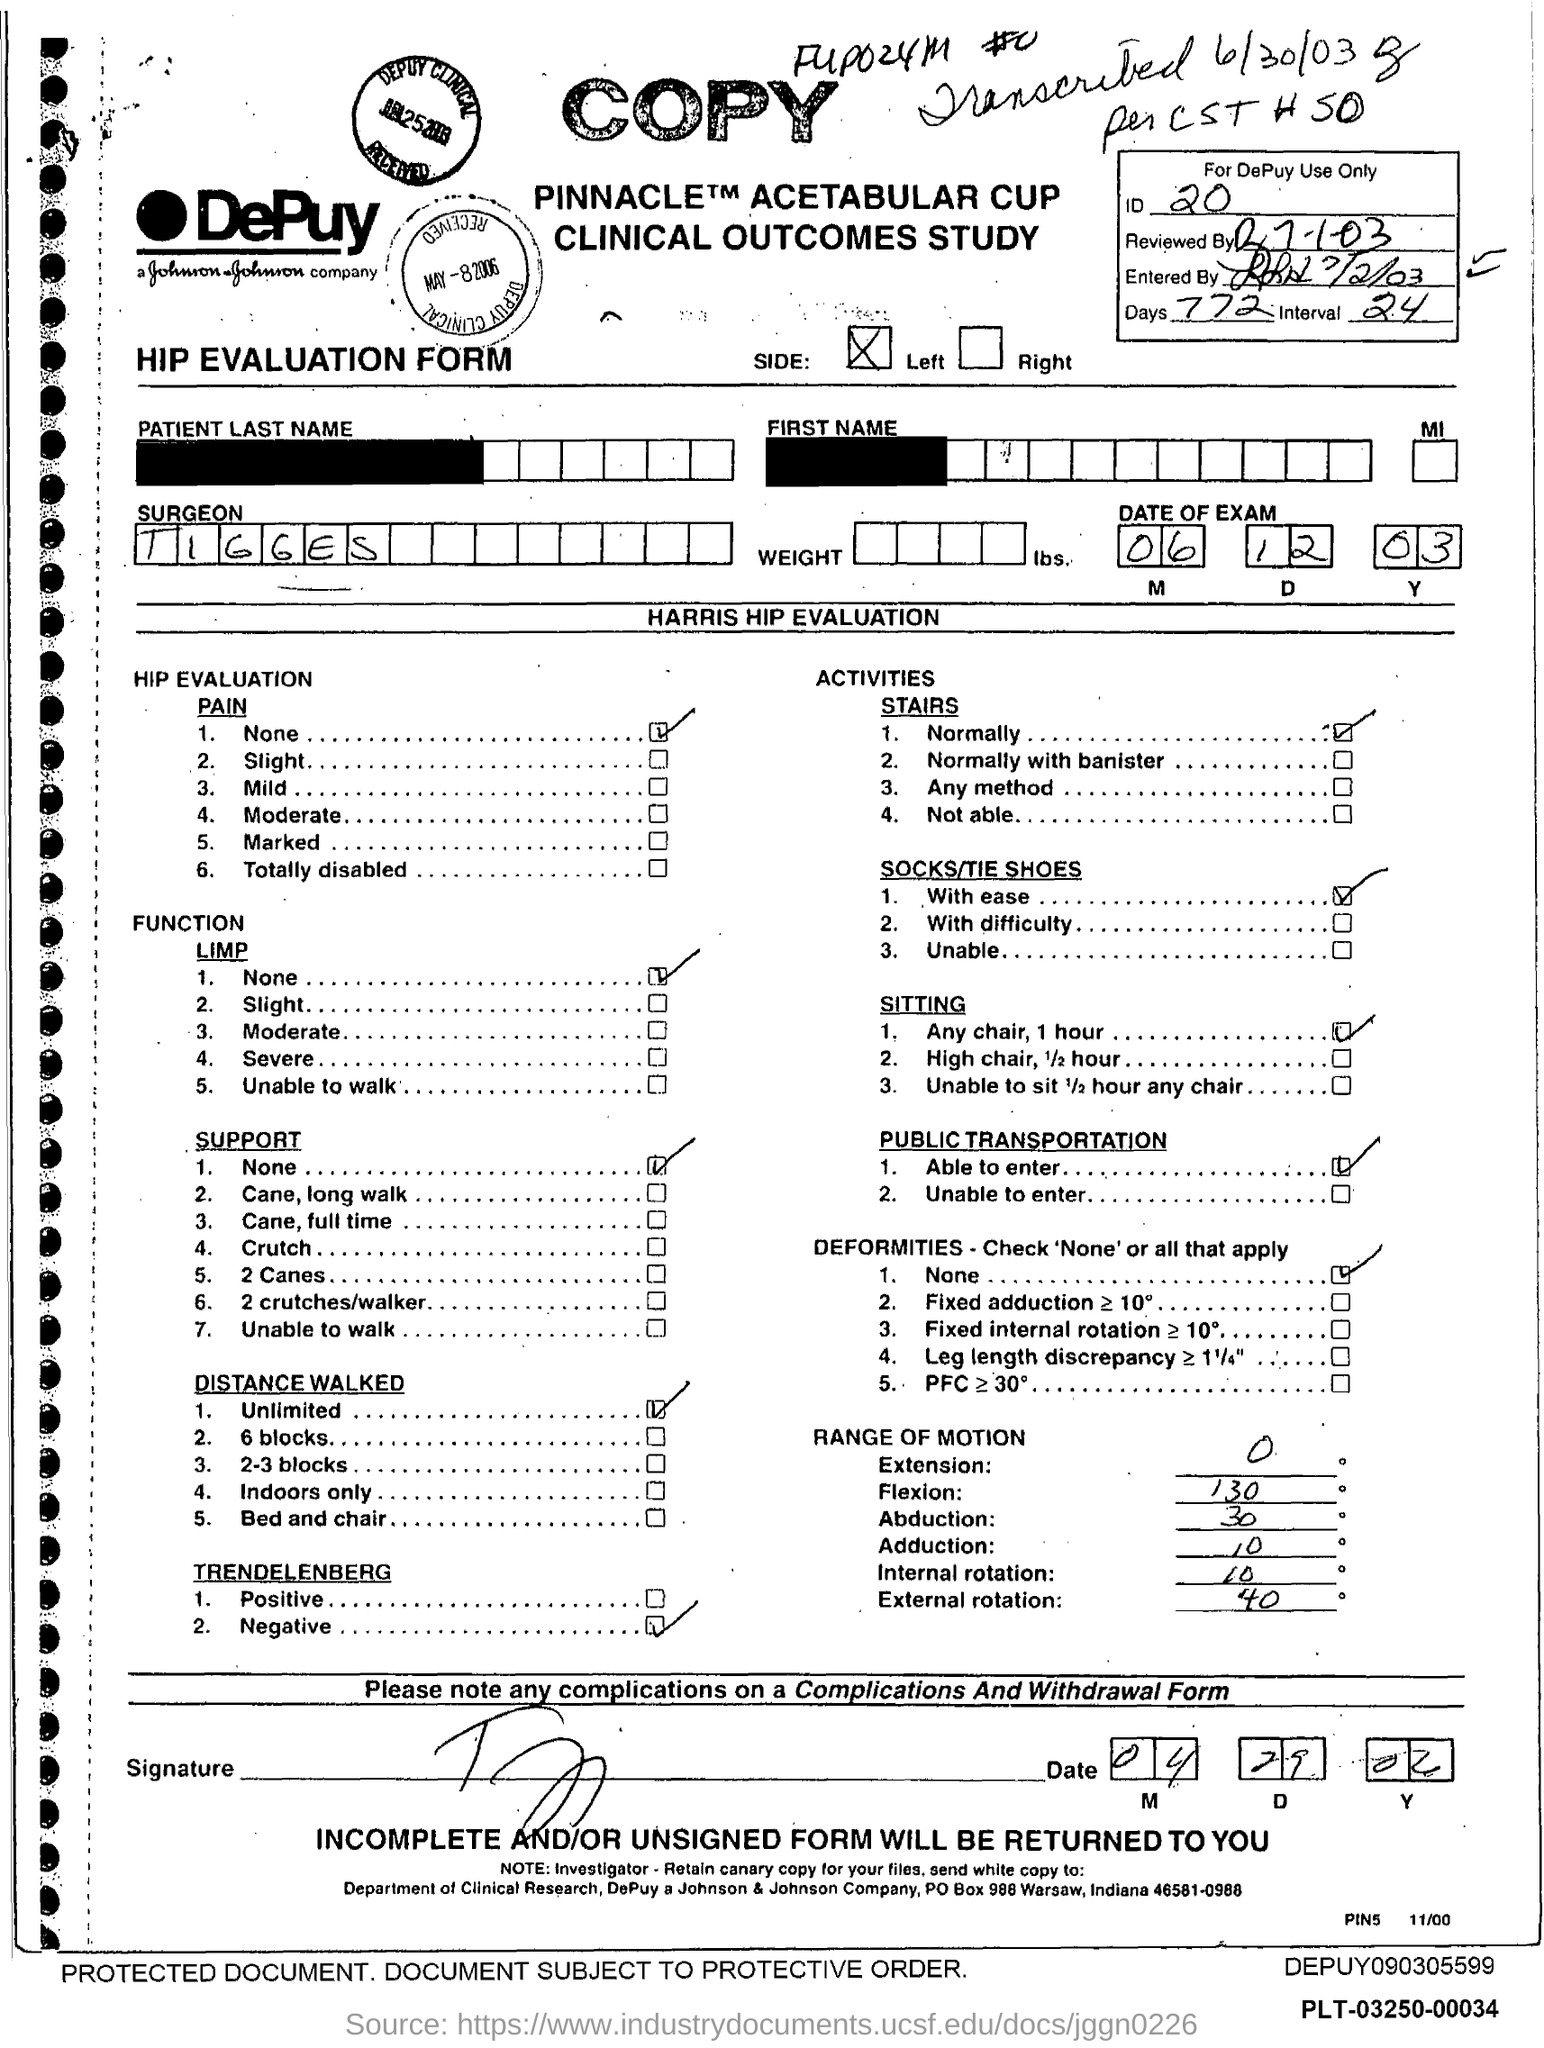Specify some key components in this picture. The interval mentioned in the form is 24.. The ID mentioned in the form is 20. The surgeon's name mentioned in the form is TIGGES. What type of form is given here? The HIP EVALUATION FORM. The date of the exam specified in the form is December 6th, 2003. 